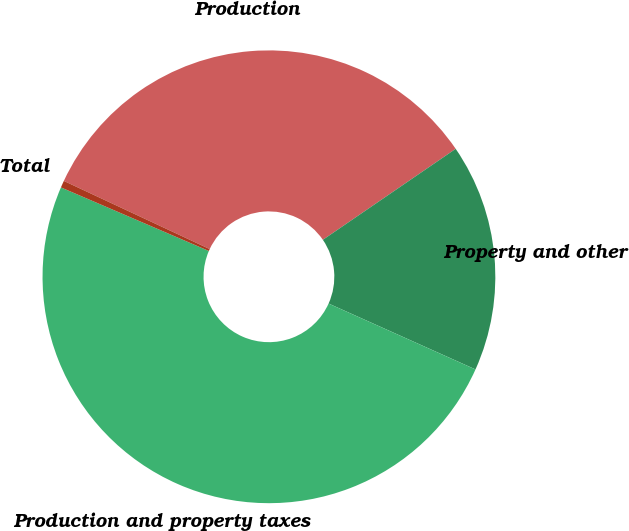<chart> <loc_0><loc_0><loc_500><loc_500><pie_chart><fcel>Production<fcel>Property and other<fcel>Production and property taxes<fcel>Total<nl><fcel>33.48%<fcel>16.27%<fcel>49.75%<fcel>0.5%<nl></chart> 